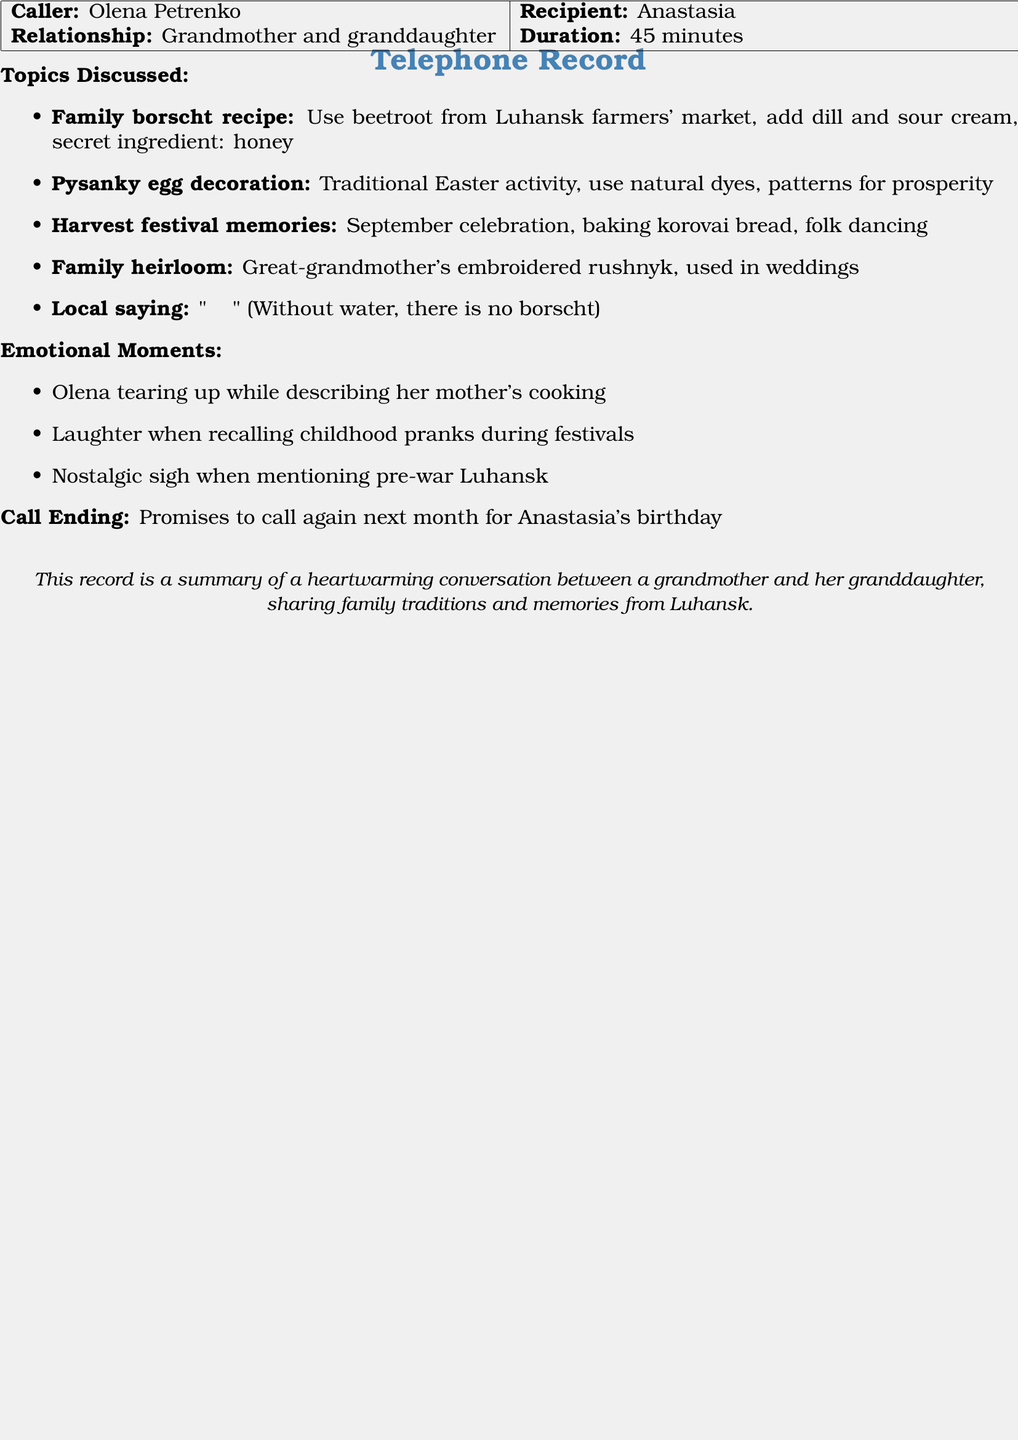What is the duration of the call? The duration of the call is mentioned in the document as 45 minutes.
Answer: 45 minutes Who called whom during the conversation? The caller's name and recipient's name are listed, showing Olena Petrenko as the caller and Anastasia as the recipient.
Answer: Olena Petrenko called Anastasia What is a secret ingredient in the borscht recipe? The document specifies that the secret ingredient in the family borscht recipe is honey.
Answer: honey What tradition involves using natural dyes? The document describes pysanky egg decoration as a traditional activity that uses natural dyes.
Answer: pysanky egg decoration What emotional moment did Olena experience? The document describes Olena tearing up while describing her mother's cooking as an emotional moment.
Answer: Olena tearing up What local saying is mentioned in the call? The document includes a local saying: "Без води і борщу нема."
Answer: "Без води і борщу нема" What kind of bread is associated with the harvest festival? The document mentions baking korovai bread during the harvest festival.
Answer: korovai bread What was promised at the end of the call? The document states that Olena promised to call again next month for Anastasia's birthday.
Answer: to call again next month 